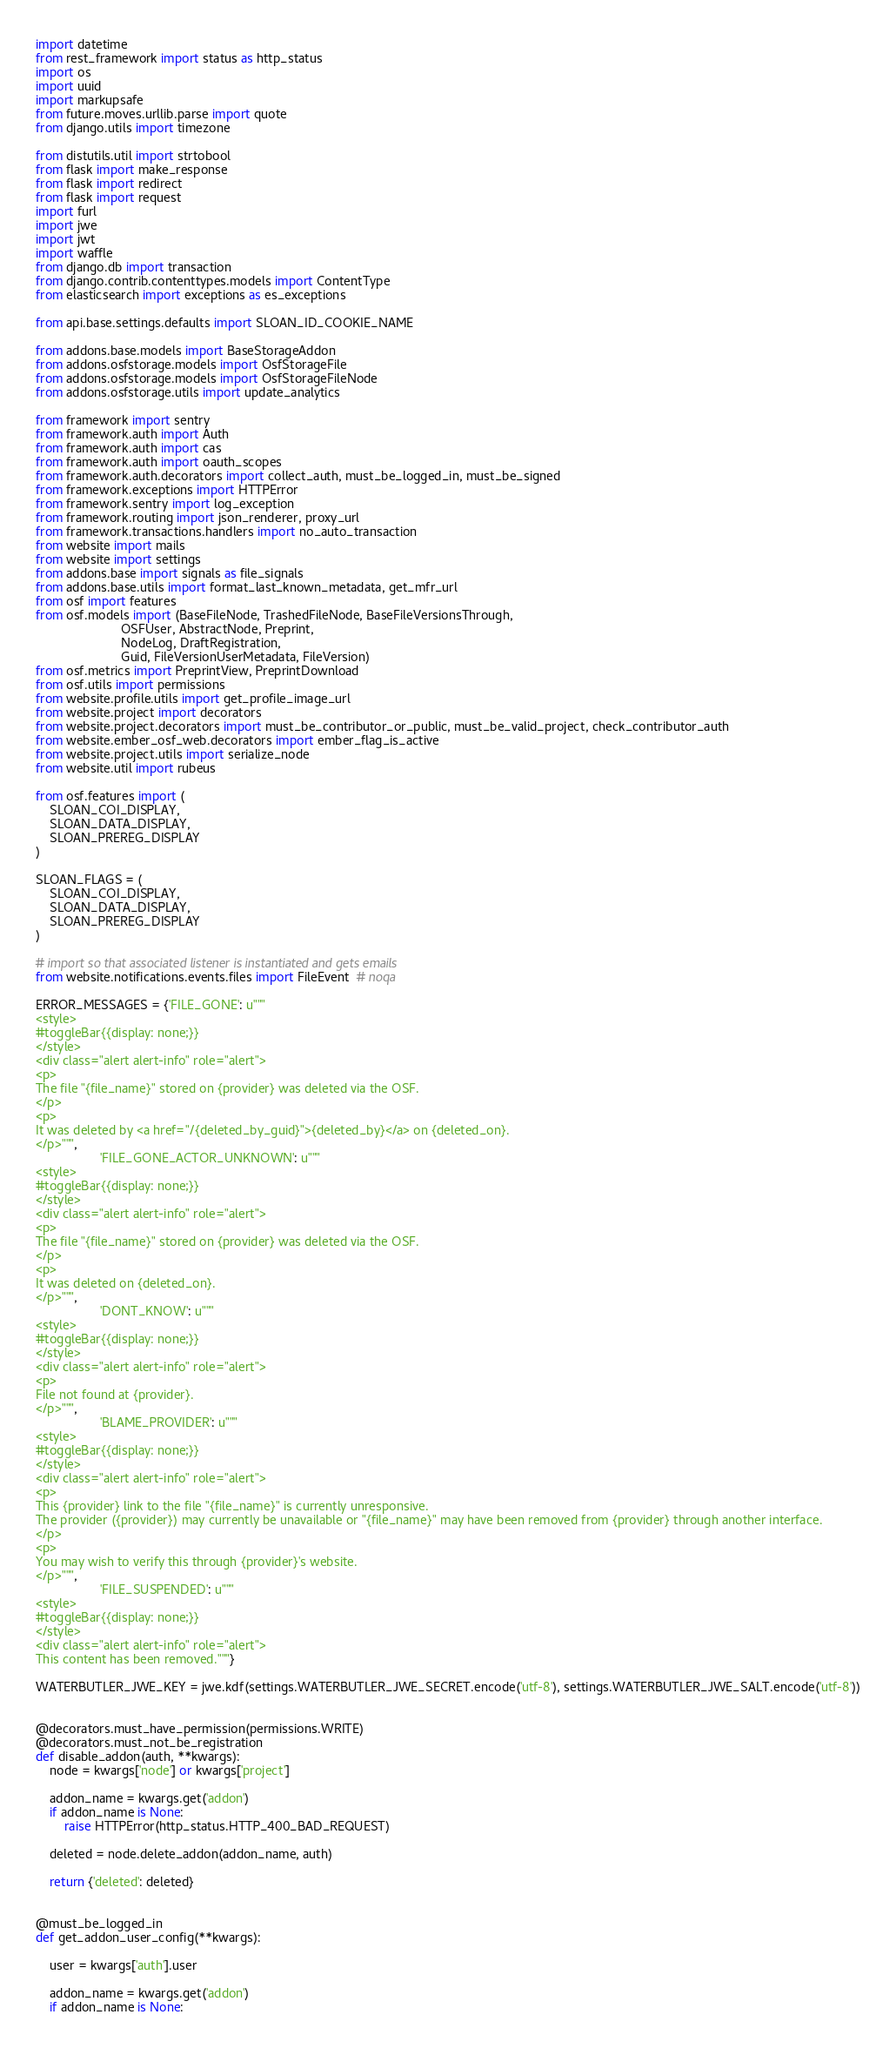<code> <loc_0><loc_0><loc_500><loc_500><_Python_>import datetime
from rest_framework import status as http_status
import os
import uuid
import markupsafe
from future.moves.urllib.parse import quote
from django.utils import timezone

from distutils.util import strtobool
from flask import make_response
from flask import redirect
from flask import request
import furl
import jwe
import jwt
import waffle
from django.db import transaction
from django.contrib.contenttypes.models import ContentType
from elasticsearch import exceptions as es_exceptions

from api.base.settings.defaults import SLOAN_ID_COOKIE_NAME

from addons.base.models import BaseStorageAddon
from addons.osfstorage.models import OsfStorageFile
from addons.osfstorage.models import OsfStorageFileNode
from addons.osfstorage.utils import update_analytics

from framework import sentry
from framework.auth import Auth
from framework.auth import cas
from framework.auth import oauth_scopes
from framework.auth.decorators import collect_auth, must_be_logged_in, must_be_signed
from framework.exceptions import HTTPError
from framework.sentry import log_exception
from framework.routing import json_renderer, proxy_url
from framework.transactions.handlers import no_auto_transaction
from website import mails
from website import settings
from addons.base import signals as file_signals
from addons.base.utils import format_last_known_metadata, get_mfr_url
from osf import features
from osf.models import (BaseFileNode, TrashedFileNode, BaseFileVersionsThrough,
                        OSFUser, AbstractNode, Preprint,
                        NodeLog, DraftRegistration,
                        Guid, FileVersionUserMetadata, FileVersion)
from osf.metrics import PreprintView, PreprintDownload
from osf.utils import permissions
from website.profile.utils import get_profile_image_url
from website.project import decorators
from website.project.decorators import must_be_contributor_or_public, must_be_valid_project, check_contributor_auth
from website.ember_osf_web.decorators import ember_flag_is_active
from website.project.utils import serialize_node
from website.util import rubeus

from osf.features import (
    SLOAN_COI_DISPLAY,
    SLOAN_DATA_DISPLAY,
    SLOAN_PREREG_DISPLAY
)

SLOAN_FLAGS = (
    SLOAN_COI_DISPLAY,
    SLOAN_DATA_DISPLAY,
    SLOAN_PREREG_DISPLAY
)

# import so that associated listener is instantiated and gets emails
from website.notifications.events.files import FileEvent  # noqa

ERROR_MESSAGES = {'FILE_GONE': u"""
<style>
#toggleBar{{display: none;}}
</style>
<div class="alert alert-info" role="alert">
<p>
The file "{file_name}" stored on {provider} was deleted via the OSF.
</p>
<p>
It was deleted by <a href="/{deleted_by_guid}">{deleted_by}</a> on {deleted_on}.
</p>""",
                  'FILE_GONE_ACTOR_UNKNOWN': u"""
<style>
#toggleBar{{display: none;}}
</style>
<div class="alert alert-info" role="alert">
<p>
The file "{file_name}" stored on {provider} was deleted via the OSF.
</p>
<p>
It was deleted on {deleted_on}.
</p>""",
                  'DONT_KNOW': u"""
<style>
#toggleBar{{display: none;}}
</style>
<div class="alert alert-info" role="alert">
<p>
File not found at {provider}.
</p>""",
                  'BLAME_PROVIDER': u"""
<style>
#toggleBar{{display: none;}}
</style>
<div class="alert alert-info" role="alert">
<p>
This {provider} link to the file "{file_name}" is currently unresponsive.
The provider ({provider}) may currently be unavailable or "{file_name}" may have been removed from {provider} through another interface.
</p>
<p>
You may wish to verify this through {provider}'s website.
</p>""",
                  'FILE_SUSPENDED': u"""
<style>
#toggleBar{{display: none;}}
</style>
<div class="alert alert-info" role="alert">
This content has been removed."""}

WATERBUTLER_JWE_KEY = jwe.kdf(settings.WATERBUTLER_JWE_SECRET.encode('utf-8'), settings.WATERBUTLER_JWE_SALT.encode('utf-8'))


@decorators.must_have_permission(permissions.WRITE)
@decorators.must_not_be_registration
def disable_addon(auth, **kwargs):
    node = kwargs['node'] or kwargs['project']

    addon_name = kwargs.get('addon')
    if addon_name is None:
        raise HTTPError(http_status.HTTP_400_BAD_REQUEST)

    deleted = node.delete_addon(addon_name, auth)

    return {'deleted': deleted}


@must_be_logged_in
def get_addon_user_config(**kwargs):

    user = kwargs['auth'].user

    addon_name = kwargs.get('addon')
    if addon_name is None:</code> 